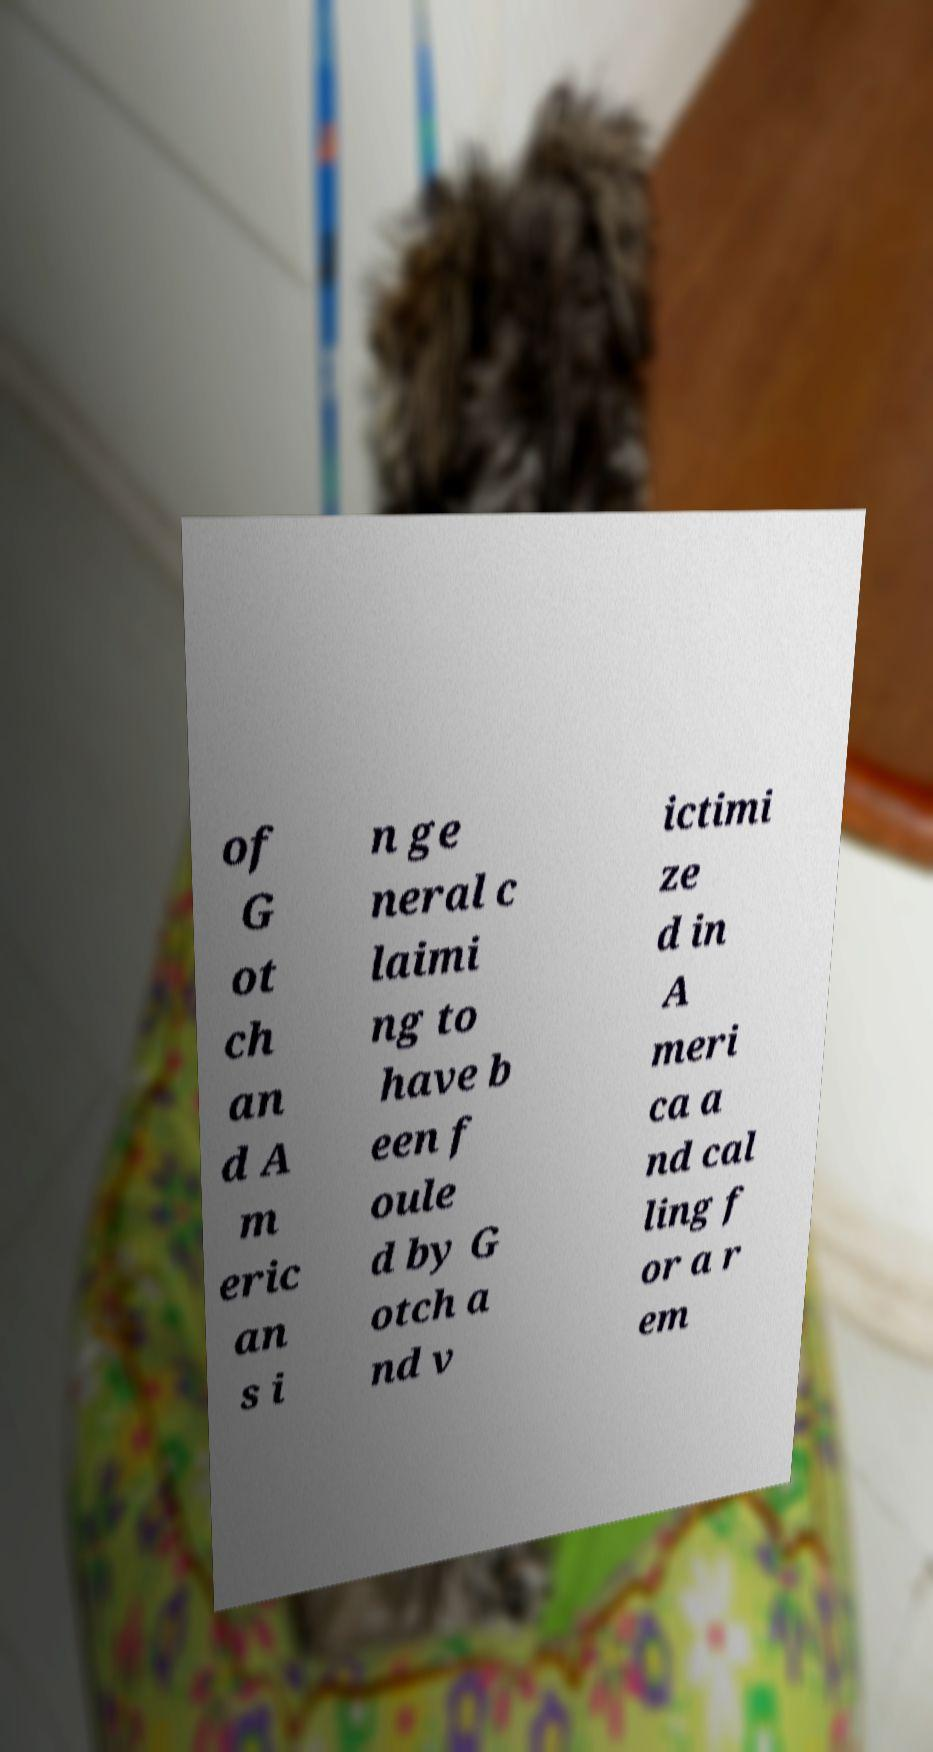Could you assist in decoding the text presented in this image and type it out clearly? of G ot ch an d A m eric an s i n ge neral c laimi ng to have b een f oule d by G otch a nd v ictimi ze d in A meri ca a nd cal ling f or a r em 